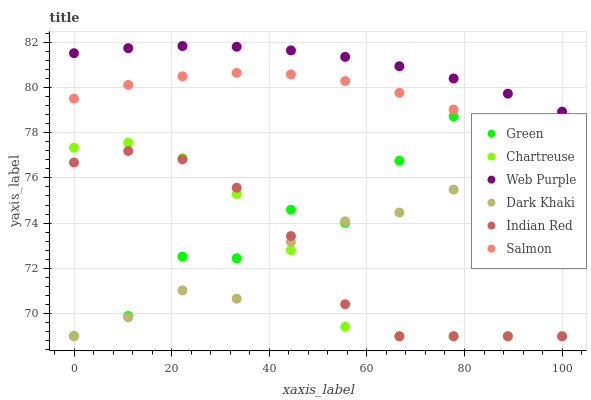Does Chartreuse have the minimum area under the curve?
Answer yes or no. Yes. Does Web Purple have the maximum area under the curve?
Answer yes or no. Yes. Does Dark Khaki have the minimum area under the curve?
Answer yes or no. No. Does Dark Khaki have the maximum area under the curve?
Answer yes or no. No. Is Web Purple the smoothest?
Answer yes or no. Yes. Is Green the roughest?
Answer yes or no. Yes. Is Dark Khaki the smoothest?
Answer yes or no. No. Is Dark Khaki the roughest?
Answer yes or no. No. Does Dark Khaki have the lowest value?
Answer yes or no. Yes. Does Web Purple have the lowest value?
Answer yes or no. No. Does Web Purple have the highest value?
Answer yes or no. Yes. Does Dark Khaki have the highest value?
Answer yes or no. No. Is Green less than Web Purple?
Answer yes or no. Yes. Is Web Purple greater than Salmon?
Answer yes or no. Yes. Does Salmon intersect Green?
Answer yes or no. Yes. Is Salmon less than Green?
Answer yes or no. No. Is Salmon greater than Green?
Answer yes or no. No. Does Green intersect Web Purple?
Answer yes or no. No. 